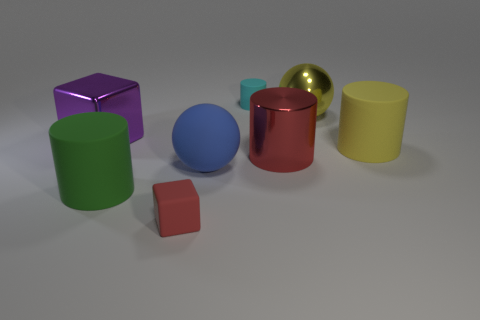What shape is the small red thing that is made of the same material as the big yellow cylinder?
Offer a terse response. Cube. Is there anything else that is the same color as the metallic ball?
Offer a terse response. Yes. The shiny cylinder that is the same color as the small rubber cube is what size?
Offer a terse response. Large. Is the number of large red metal cylinders that are behind the large red shiny object greater than the number of big metal cubes?
Provide a short and direct response. No. There is a yellow metallic thing; is its shape the same as the big green matte thing that is to the left of the cyan cylinder?
Provide a succinct answer. No. What number of cyan balls are the same size as the purple metal block?
Offer a very short reply. 0. There is a cube that is right of the large matte thing to the left of the big rubber ball; what number of large blue rubber balls are to the left of it?
Give a very brief answer. 0. Are there an equal number of cyan cylinders right of the blue matte thing and big blue matte things behind the red metal cylinder?
Provide a short and direct response. No. How many shiny things have the same shape as the green matte object?
Keep it short and to the point. 1. Is there a green cylinder that has the same material as the red block?
Provide a succinct answer. Yes. 